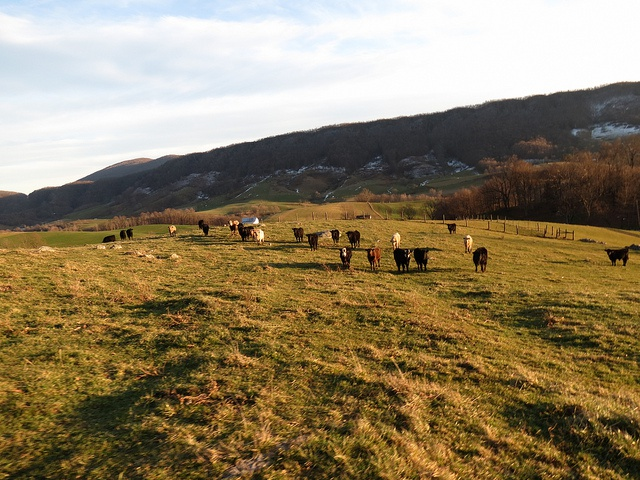Describe the objects in this image and their specific colors. I can see cow in lightblue, black, olive, and maroon tones, cow in lightblue, black, olive, and maroon tones, cow in lightblue, black, maroon, and olive tones, cow in lightblue, black, brown, and maroon tones, and cow in lightblue, black, maroon, and olive tones in this image. 